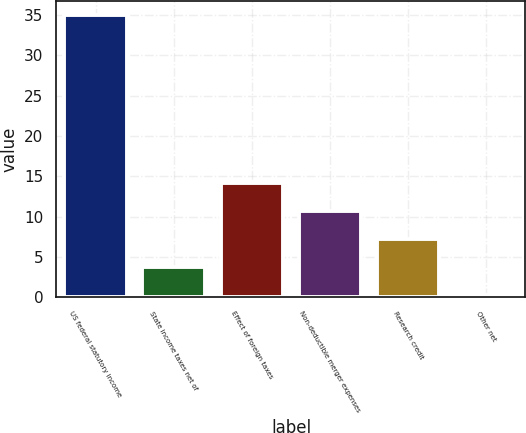<chart> <loc_0><loc_0><loc_500><loc_500><bar_chart><fcel>US federal statutory income<fcel>State income taxes net of<fcel>Effect of foreign taxes<fcel>Non-deductible merger expenses<fcel>Research credit<fcel>Other net<nl><fcel>35<fcel>3.68<fcel>14.12<fcel>10.64<fcel>7.16<fcel>0.2<nl></chart> 